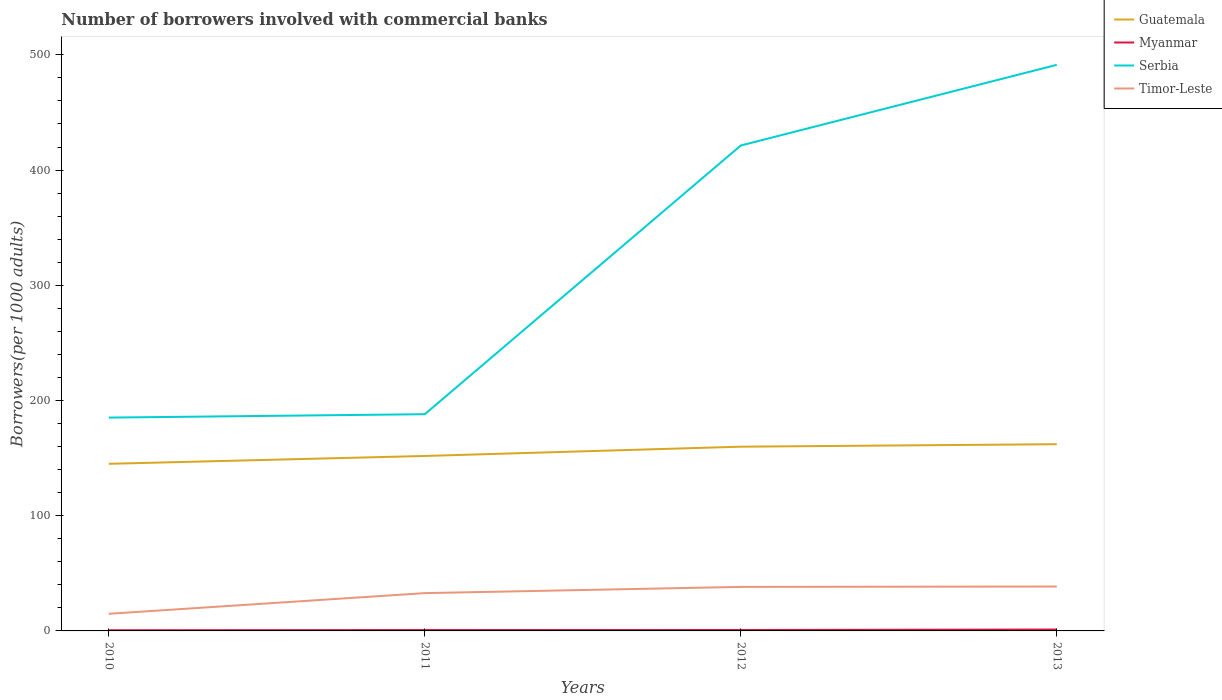How many different coloured lines are there?
Offer a terse response. 4. Is the number of lines equal to the number of legend labels?
Offer a terse response. Yes. Across all years, what is the maximum number of borrowers involved with commercial banks in Timor-Leste?
Provide a short and direct response. 14.87. What is the total number of borrowers involved with commercial banks in Myanmar in the graph?
Provide a short and direct response. -0.03. What is the difference between the highest and the second highest number of borrowers involved with commercial banks in Serbia?
Your response must be concise. 306.16. What is the difference between two consecutive major ticks on the Y-axis?
Your answer should be very brief. 100. How many legend labels are there?
Your response must be concise. 4. What is the title of the graph?
Make the answer very short. Number of borrowers involved with commercial banks. Does "Barbados" appear as one of the legend labels in the graph?
Ensure brevity in your answer.  No. What is the label or title of the Y-axis?
Your answer should be compact. Borrowers(per 1000 adults). What is the Borrowers(per 1000 adults) in Guatemala in 2010?
Offer a very short reply. 145.05. What is the Borrowers(per 1000 adults) in Myanmar in 2010?
Your response must be concise. 0.58. What is the Borrowers(per 1000 adults) of Serbia in 2010?
Provide a short and direct response. 185.15. What is the Borrowers(per 1000 adults) in Timor-Leste in 2010?
Offer a very short reply. 14.87. What is the Borrowers(per 1000 adults) of Guatemala in 2011?
Offer a very short reply. 151.85. What is the Borrowers(per 1000 adults) of Myanmar in 2011?
Offer a very short reply. 0.76. What is the Borrowers(per 1000 adults) of Serbia in 2011?
Your answer should be very brief. 188.1. What is the Borrowers(per 1000 adults) in Timor-Leste in 2011?
Give a very brief answer. 32.81. What is the Borrowers(per 1000 adults) in Guatemala in 2012?
Offer a terse response. 159.9. What is the Borrowers(per 1000 adults) of Myanmar in 2012?
Ensure brevity in your answer.  0.8. What is the Borrowers(per 1000 adults) in Serbia in 2012?
Give a very brief answer. 421.31. What is the Borrowers(per 1000 adults) of Timor-Leste in 2012?
Keep it short and to the point. 38.21. What is the Borrowers(per 1000 adults) of Guatemala in 2013?
Your response must be concise. 162.06. What is the Borrowers(per 1000 adults) of Myanmar in 2013?
Your answer should be very brief. 1.22. What is the Borrowers(per 1000 adults) of Serbia in 2013?
Ensure brevity in your answer.  491.32. What is the Borrowers(per 1000 adults) in Timor-Leste in 2013?
Provide a short and direct response. 38.53. Across all years, what is the maximum Borrowers(per 1000 adults) in Guatemala?
Your answer should be very brief. 162.06. Across all years, what is the maximum Borrowers(per 1000 adults) in Myanmar?
Give a very brief answer. 1.22. Across all years, what is the maximum Borrowers(per 1000 adults) of Serbia?
Offer a very short reply. 491.32. Across all years, what is the maximum Borrowers(per 1000 adults) of Timor-Leste?
Make the answer very short. 38.53. Across all years, what is the minimum Borrowers(per 1000 adults) of Guatemala?
Offer a very short reply. 145.05. Across all years, what is the minimum Borrowers(per 1000 adults) of Myanmar?
Offer a terse response. 0.58. Across all years, what is the minimum Borrowers(per 1000 adults) in Serbia?
Offer a terse response. 185.15. Across all years, what is the minimum Borrowers(per 1000 adults) of Timor-Leste?
Ensure brevity in your answer.  14.87. What is the total Borrowers(per 1000 adults) in Guatemala in the graph?
Offer a very short reply. 618.85. What is the total Borrowers(per 1000 adults) of Myanmar in the graph?
Your answer should be compact. 3.36. What is the total Borrowers(per 1000 adults) in Serbia in the graph?
Your answer should be compact. 1285.88. What is the total Borrowers(per 1000 adults) of Timor-Leste in the graph?
Keep it short and to the point. 124.42. What is the difference between the Borrowers(per 1000 adults) in Guatemala in 2010 and that in 2011?
Offer a very short reply. -6.8. What is the difference between the Borrowers(per 1000 adults) of Myanmar in 2010 and that in 2011?
Your response must be concise. -0.18. What is the difference between the Borrowers(per 1000 adults) in Serbia in 2010 and that in 2011?
Offer a very short reply. -2.94. What is the difference between the Borrowers(per 1000 adults) in Timor-Leste in 2010 and that in 2011?
Offer a terse response. -17.94. What is the difference between the Borrowers(per 1000 adults) in Guatemala in 2010 and that in 2012?
Keep it short and to the point. -14.85. What is the difference between the Borrowers(per 1000 adults) of Myanmar in 2010 and that in 2012?
Provide a succinct answer. -0.21. What is the difference between the Borrowers(per 1000 adults) in Serbia in 2010 and that in 2012?
Ensure brevity in your answer.  -236.15. What is the difference between the Borrowers(per 1000 adults) in Timor-Leste in 2010 and that in 2012?
Your response must be concise. -23.34. What is the difference between the Borrowers(per 1000 adults) in Guatemala in 2010 and that in 2013?
Give a very brief answer. -17.01. What is the difference between the Borrowers(per 1000 adults) of Myanmar in 2010 and that in 2013?
Make the answer very short. -0.64. What is the difference between the Borrowers(per 1000 adults) of Serbia in 2010 and that in 2013?
Ensure brevity in your answer.  -306.16. What is the difference between the Borrowers(per 1000 adults) of Timor-Leste in 2010 and that in 2013?
Offer a terse response. -23.66. What is the difference between the Borrowers(per 1000 adults) of Guatemala in 2011 and that in 2012?
Provide a short and direct response. -8.05. What is the difference between the Borrowers(per 1000 adults) in Myanmar in 2011 and that in 2012?
Keep it short and to the point. -0.03. What is the difference between the Borrowers(per 1000 adults) in Serbia in 2011 and that in 2012?
Your answer should be compact. -233.21. What is the difference between the Borrowers(per 1000 adults) in Timor-Leste in 2011 and that in 2012?
Your response must be concise. -5.4. What is the difference between the Borrowers(per 1000 adults) of Guatemala in 2011 and that in 2013?
Make the answer very short. -10.21. What is the difference between the Borrowers(per 1000 adults) in Myanmar in 2011 and that in 2013?
Make the answer very short. -0.45. What is the difference between the Borrowers(per 1000 adults) of Serbia in 2011 and that in 2013?
Give a very brief answer. -303.22. What is the difference between the Borrowers(per 1000 adults) in Timor-Leste in 2011 and that in 2013?
Your answer should be compact. -5.72. What is the difference between the Borrowers(per 1000 adults) of Guatemala in 2012 and that in 2013?
Your answer should be very brief. -2.16. What is the difference between the Borrowers(per 1000 adults) of Myanmar in 2012 and that in 2013?
Keep it short and to the point. -0.42. What is the difference between the Borrowers(per 1000 adults) in Serbia in 2012 and that in 2013?
Offer a very short reply. -70.01. What is the difference between the Borrowers(per 1000 adults) of Timor-Leste in 2012 and that in 2013?
Give a very brief answer. -0.32. What is the difference between the Borrowers(per 1000 adults) of Guatemala in 2010 and the Borrowers(per 1000 adults) of Myanmar in 2011?
Your answer should be compact. 144.29. What is the difference between the Borrowers(per 1000 adults) in Guatemala in 2010 and the Borrowers(per 1000 adults) in Serbia in 2011?
Your answer should be very brief. -43.05. What is the difference between the Borrowers(per 1000 adults) of Guatemala in 2010 and the Borrowers(per 1000 adults) of Timor-Leste in 2011?
Offer a very short reply. 112.24. What is the difference between the Borrowers(per 1000 adults) of Myanmar in 2010 and the Borrowers(per 1000 adults) of Serbia in 2011?
Your answer should be compact. -187.52. What is the difference between the Borrowers(per 1000 adults) in Myanmar in 2010 and the Borrowers(per 1000 adults) in Timor-Leste in 2011?
Your answer should be compact. -32.23. What is the difference between the Borrowers(per 1000 adults) in Serbia in 2010 and the Borrowers(per 1000 adults) in Timor-Leste in 2011?
Offer a terse response. 152.34. What is the difference between the Borrowers(per 1000 adults) in Guatemala in 2010 and the Borrowers(per 1000 adults) in Myanmar in 2012?
Give a very brief answer. 144.25. What is the difference between the Borrowers(per 1000 adults) of Guatemala in 2010 and the Borrowers(per 1000 adults) of Serbia in 2012?
Your response must be concise. -276.26. What is the difference between the Borrowers(per 1000 adults) of Guatemala in 2010 and the Borrowers(per 1000 adults) of Timor-Leste in 2012?
Give a very brief answer. 106.84. What is the difference between the Borrowers(per 1000 adults) of Myanmar in 2010 and the Borrowers(per 1000 adults) of Serbia in 2012?
Your answer should be very brief. -420.73. What is the difference between the Borrowers(per 1000 adults) in Myanmar in 2010 and the Borrowers(per 1000 adults) in Timor-Leste in 2012?
Keep it short and to the point. -37.63. What is the difference between the Borrowers(per 1000 adults) in Serbia in 2010 and the Borrowers(per 1000 adults) in Timor-Leste in 2012?
Your answer should be very brief. 146.95. What is the difference between the Borrowers(per 1000 adults) of Guatemala in 2010 and the Borrowers(per 1000 adults) of Myanmar in 2013?
Keep it short and to the point. 143.83. What is the difference between the Borrowers(per 1000 adults) of Guatemala in 2010 and the Borrowers(per 1000 adults) of Serbia in 2013?
Your answer should be compact. -346.26. What is the difference between the Borrowers(per 1000 adults) in Guatemala in 2010 and the Borrowers(per 1000 adults) in Timor-Leste in 2013?
Offer a terse response. 106.52. What is the difference between the Borrowers(per 1000 adults) in Myanmar in 2010 and the Borrowers(per 1000 adults) in Serbia in 2013?
Your answer should be compact. -490.73. What is the difference between the Borrowers(per 1000 adults) of Myanmar in 2010 and the Borrowers(per 1000 adults) of Timor-Leste in 2013?
Offer a terse response. -37.95. What is the difference between the Borrowers(per 1000 adults) of Serbia in 2010 and the Borrowers(per 1000 adults) of Timor-Leste in 2013?
Keep it short and to the point. 146.62. What is the difference between the Borrowers(per 1000 adults) in Guatemala in 2011 and the Borrowers(per 1000 adults) in Myanmar in 2012?
Keep it short and to the point. 151.05. What is the difference between the Borrowers(per 1000 adults) in Guatemala in 2011 and the Borrowers(per 1000 adults) in Serbia in 2012?
Offer a terse response. -269.46. What is the difference between the Borrowers(per 1000 adults) in Guatemala in 2011 and the Borrowers(per 1000 adults) in Timor-Leste in 2012?
Give a very brief answer. 113.64. What is the difference between the Borrowers(per 1000 adults) of Myanmar in 2011 and the Borrowers(per 1000 adults) of Serbia in 2012?
Provide a short and direct response. -420.54. What is the difference between the Borrowers(per 1000 adults) in Myanmar in 2011 and the Borrowers(per 1000 adults) in Timor-Leste in 2012?
Make the answer very short. -37.44. What is the difference between the Borrowers(per 1000 adults) of Serbia in 2011 and the Borrowers(per 1000 adults) of Timor-Leste in 2012?
Give a very brief answer. 149.89. What is the difference between the Borrowers(per 1000 adults) of Guatemala in 2011 and the Borrowers(per 1000 adults) of Myanmar in 2013?
Offer a terse response. 150.63. What is the difference between the Borrowers(per 1000 adults) in Guatemala in 2011 and the Borrowers(per 1000 adults) in Serbia in 2013?
Your answer should be very brief. -339.47. What is the difference between the Borrowers(per 1000 adults) of Guatemala in 2011 and the Borrowers(per 1000 adults) of Timor-Leste in 2013?
Offer a very short reply. 113.31. What is the difference between the Borrowers(per 1000 adults) of Myanmar in 2011 and the Borrowers(per 1000 adults) of Serbia in 2013?
Give a very brief answer. -490.55. What is the difference between the Borrowers(per 1000 adults) in Myanmar in 2011 and the Borrowers(per 1000 adults) in Timor-Leste in 2013?
Offer a terse response. -37.77. What is the difference between the Borrowers(per 1000 adults) of Serbia in 2011 and the Borrowers(per 1000 adults) of Timor-Leste in 2013?
Provide a succinct answer. 149.56. What is the difference between the Borrowers(per 1000 adults) in Guatemala in 2012 and the Borrowers(per 1000 adults) in Myanmar in 2013?
Provide a short and direct response. 158.68. What is the difference between the Borrowers(per 1000 adults) in Guatemala in 2012 and the Borrowers(per 1000 adults) in Serbia in 2013?
Offer a very short reply. -331.42. What is the difference between the Borrowers(per 1000 adults) of Guatemala in 2012 and the Borrowers(per 1000 adults) of Timor-Leste in 2013?
Keep it short and to the point. 121.36. What is the difference between the Borrowers(per 1000 adults) in Myanmar in 2012 and the Borrowers(per 1000 adults) in Serbia in 2013?
Make the answer very short. -490.52. What is the difference between the Borrowers(per 1000 adults) of Myanmar in 2012 and the Borrowers(per 1000 adults) of Timor-Leste in 2013?
Give a very brief answer. -37.74. What is the difference between the Borrowers(per 1000 adults) in Serbia in 2012 and the Borrowers(per 1000 adults) in Timor-Leste in 2013?
Provide a succinct answer. 382.77. What is the average Borrowers(per 1000 adults) in Guatemala per year?
Keep it short and to the point. 154.71. What is the average Borrowers(per 1000 adults) of Myanmar per year?
Provide a short and direct response. 0.84. What is the average Borrowers(per 1000 adults) of Serbia per year?
Keep it short and to the point. 321.47. What is the average Borrowers(per 1000 adults) of Timor-Leste per year?
Your answer should be very brief. 31.11. In the year 2010, what is the difference between the Borrowers(per 1000 adults) of Guatemala and Borrowers(per 1000 adults) of Myanmar?
Keep it short and to the point. 144.47. In the year 2010, what is the difference between the Borrowers(per 1000 adults) of Guatemala and Borrowers(per 1000 adults) of Serbia?
Offer a very short reply. -40.1. In the year 2010, what is the difference between the Borrowers(per 1000 adults) in Guatemala and Borrowers(per 1000 adults) in Timor-Leste?
Offer a very short reply. 130.18. In the year 2010, what is the difference between the Borrowers(per 1000 adults) of Myanmar and Borrowers(per 1000 adults) of Serbia?
Offer a very short reply. -184.57. In the year 2010, what is the difference between the Borrowers(per 1000 adults) of Myanmar and Borrowers(per 1000 adults) of Timor-Leste?
Your answer should be compact. -14.29. In the year 2010, what is the difference between the Borrowers(per 1000 adults) in Serbia and Borrowers(per 1000 adults) in Timor-Leste?
Give a very brief answer. 170.28. In the year 2011, what is the difference between the Borrowers(per 1000 adults) in Guatemala and Borrowers(per 1000 adults) in Myanmar?
Offer a terse response. 151.08. In the year 2011, what is the difference between the Borrowers(per 1000 adults) of Guatemala and Borrowers(per 1000 adults) of Serbia?
Your answer should be very brief. -36.25. In the year 2011, what is the difference between the Borrowers(per 1000 adults) in Guatemala and Borrowers(per 1000 adults) in Timor-Leste?
Make the answer very short. 119.04. In the year 2011, what is the difference between the Borrowers(per 1000 adults) of Myanmar and Borrowers(per 1000 adults) of Serbia?
Provide a succinct answer. -187.33. In the year 2011, what is the difference between the Borrowers(per 1000 adults) of Myanmar and Borrowers(per 1000 adults) of Timor-Leste?
Provide a succinct answer. -32.05. In the year 2011, what is the difference between the Borrowers(per 1000 adults) of Serbia and Borrowers(per 1000 adults) of Timor-Leste?
Ensure brevity in your answer.  155.29. In the year 2012, what is the difference between the Borrowers(per 1000 adults) of Guatemala and Borrowers(per 1000 adults) of Myanmar?
Ensure brevity in your answer.  159.1. In the year 2012, what is the difference between the Borrowers(per 1000 adults) of Guatemala and Borrowers(per 1000 adults) of Serbia?
Your answer should be very brief. -261.41. In the year 2012, what is the difference between the Borrowers(per 1000 adults) in Guatemala and Borrowers(per 1000 adults) in Timor-Leste?
Your response must be concise. 121.69. In the year 2012, what is the difference between the Borrowers(per 1000 adults) in Myanmar and Borrowers(per 1000 adults) in Serbia?
Your response must be concise. -420.51. In the year 2012, what is the difference between the Borrowers(per 1000 adults) of Myanmar and Borrowers(per 1000 adults) of Timor-Leste?
Your answer should be very brief. -37.41. In the year 2012, what is the difference between the Borrowers(per 1000 adults) of Serbia and Borrowers(per 1000 adults) of Timor-Leste?
Keep it short and to the point. 383.1. In the year 2013, what is the difference between the Borrowers(per 1000 adults) in Guatemala and Borrowers(per 1000 adults) in Myanmar?
Your response must be concise. 160.84. In the year 2013, what is the difference between the Borrowers(per 1000 adults) of Guatemala and Borrowers(per 1000 adults) of Serbia?
Keep it short and to the point. -329.26. In the year 2013, what is the difference between the Borrowers(per 1000 adults) in Guatemala and Borrowers(per 1000 adults) in Timor-Leste?
Give a very brief answer. 123.52. In the year 2013, what is the difference between the Borrowers(per 1000 adults) of Myanmar and Borrowers(per 1000 adults) of Serbia?
Your answer should be compact. -490.1. In the year 2013, what is the difference between the Borrowers(per 1000 adults) of Myanmar and Borrowers(per 1000 adults) of Timor-Leste?
Offer a very short reply. -37.32. In the year 2013, what is the difference between the Borrowers(per 1000 adults) in Serbia and Borrowers(per 1000 adults) in Timor-Leste?
Your answer should be compact. 452.78. What is the ratio of the Borrowers(per 1000 adults) in Guatemala in 2010 to that in 2011?
Offer a terse response. 0.96. What is the ratio of the Borrowers(per 1000 adults) in Myanmar in 2010 to that in 2011?
Your answer should be very brief. 0.76. What is the ratio of the Borrowers(per 1000 adults) of Serbia in 2010 to that in 2011?
Provide a short and direct response. 0.98. What is the ratio of the Borrowers(per 1000 adults) of Timor-Leste in 2010 to that in 2011?
Your answer should be compact. 0.45. What is the ratio of the Borrowers(per 1000 adults) of Guatemala in 2010 to that in 2012?
Keep it short and to the point. 0.91. What is the ratio of the Borrowers(per 1000 adults) in Myanmar in 2010 to that in 2012?
Your response must be concise. 0.73. What is the ratio of the Borrowers(per 1000 adults) of Serbia in 2010 to that in 2012?
Provide a short and direct response. 0.44. What is the ratio of the Borrowers(per 1000 adults) in Timor-Leste in 2010 to that in 2012?
Your answer should be very brief. 0.39. What is the ratio of the Borrowers(per 1000 adults) in Guatemala in 2010 to that in 2013?
Provide a succinct answer. 0.9. What is the ratio of the Borrowers(per 1000 adults) of Myanmar in 2010 to that in 2013?
Make the answer very short. 0.48. What is the ratio of the Borrowers(per 1000 adults) of Serbia in 2010 to that in 2013?
Provide a succinct answer. 0.38. What is the ratio of the Borrowers(per 1000 adults) in Timor-Leste in 2010 to that in 2013?
Make the answer very short. 0.39. What is the ratio of the Borrowers(per 1000 adults) of Guatemala in 2011 to that in 2012?
Your response must be concise. 0.95. What is the ratio of the Borrowers(per 1000 adults) of Myanmar in 2011 to that in 2012?
Offer a very short reply. 0.96. What is the ratio of the Borrowers(per 1000 adults) of Serbia in 2011 to that in 2012?
Keep it short and to the point. 0.45. What is the ratio of the Borrowers(per 1000 adults) of Timor-Leste in 2011 to that in 2012?
Give a very brief answer. 0.86. What is the ratio of the Borrowers(per 1000 adults) of Guatemala in 2011 to that in 2013?
Provide a short and direct response. 0.94. What is the ratio of the Borrowers(per 1000 adults) of Myanmar in 2011 to that in 2013?
Make the answer very short. 0.63. What is the ratio of the Borrowers(per 1000 adults) of Serbia in 2011 to that in 2013?
Give a very brief answer. 0.38. What is the ratio of the Borrowers(per 1000 adults) of Timor-Leste in 2011 to that in 2013?
Provide a succinct answer. 0.85. What is the ratio of the Borrowers(per 1000 adults) in Guatemala in 2012 to that in 2013?
Keep it short and to the point. 0.99. What is the ratio of the Borrowers(per 1000 adults) in Myanmar in 2012 to that in 2013?
Ensure brevity in your answer.  0.65. What is the ratio of the Borrowers(per 1000 adults) of Serbia in 2012 to that in 2013?
Keep it short and to the point. 0.86. What is the ratio of the Borrowers(per 1000 adults) of Timor-Leste in 2012 to that in 2013?
Offer a very short reply. 0.99. What is the difference between the highest and the second highest Borrowers(per 1000 adults) in Guatemala?
Provide a succinct answer. 2.16. What is the difference between the highest and the second highest Borrowers(per 1000 adults) of Myanmar?
Your response must be concise. 0.42. What is the difference between the highest and the second highest Borrowers(per 1000 adults) of Serbia?
Your answer should be very brief. 70.01. What is the difference between the highest and the second highest Borrowers(per 1000 adults) in Timor-Leste?
Give a very brief answer. 0.32. What is the difference between the highest and the lowest Borrowers(per 1000 adults) of Guatemala?
Provide a short and direct response. 17.01. What is the difference between the highest and the lowest Borrowers(per 1000 adults) in Myanmar?
Your answer should be very brief. 0.64. What is the difference between the highest and the lowest Borrowers(per 1000 adults) of Serbia?
Offer a very short reply. 306.16. What is the difference between the highest and the lowest Borrowers(per 1000 adults) in Timor-Leste?
Provide a short and direct response. 23.66. 